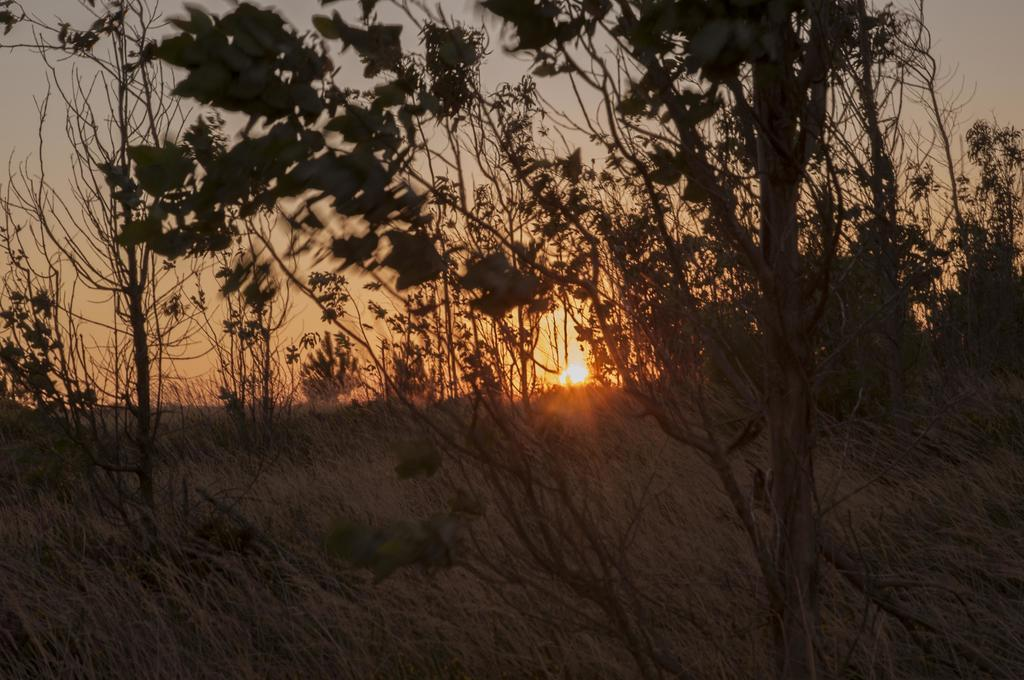What type of setting is depicted in the image? The image is an outside view. What can be seen in the foreground of the image? There are plants in the foreground of the image. What is visible in the background of the image? The sky is visible in the background of the image. Can the sun be seen in the image? Yes, the sun is observable in the sky. What type of shoes can be seen in the image? There are no shoes present in the image; it is an outside view with plants and the sky visible. 